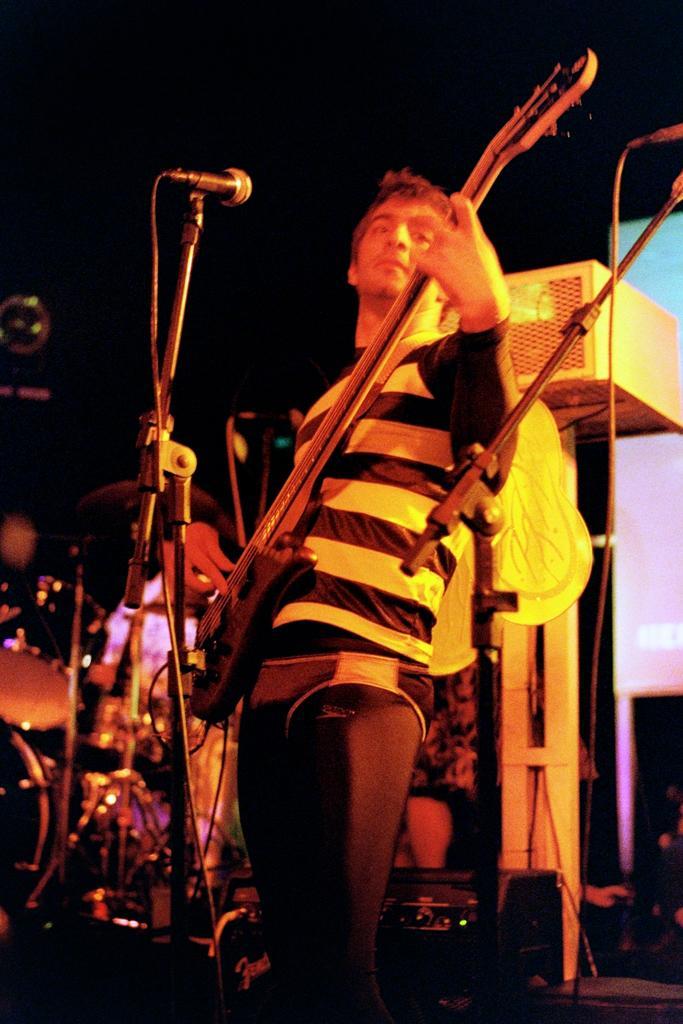Can you describe this image briefly? Here we can see a man standing and holding a guitar in his hands, and in front here is the microphone and here is the stand. 